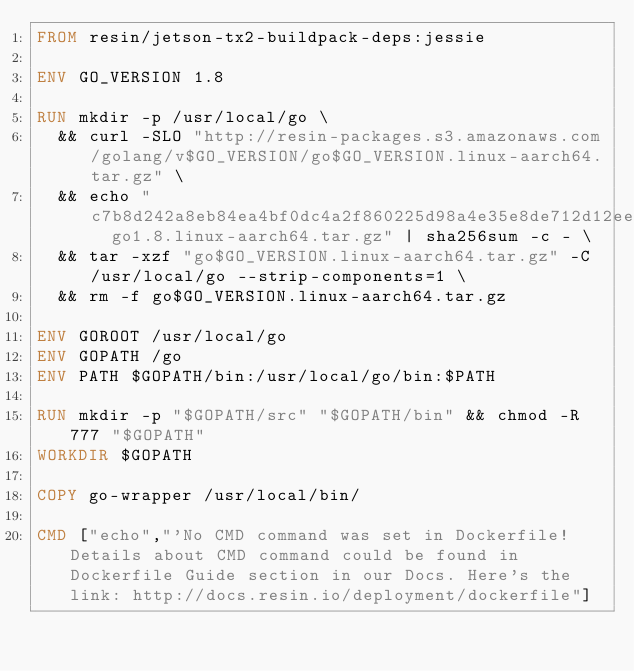<code> <loc_0><loc_0><loc_500><loc_500><_Dockerfile_>FROM resin/jetson-tx2-buildpack-deps:jessie

ENV GO_VERSION 1.8

RUN mkdir -p /usr/local/go \
	&& curl -SLO "http://resin-packages.s3.amazonaws.com/golang/v$GO_VERSION/go$GO_VERSION.linux-aarch64.tar.gz" \
	&& echo "c7b8d242a8eb84ea4bf0dc4a2f860225d98a4e35e8de712d12ee0247f1773854  go1.8.linux-aarch64.tar.gz" | sha256sum -c - \
	&& tar -xzf "go$GO_VERSION.linux-aarch64.tar.gz" -C /usr/local/go --strip-components=1 \
	&& rm -f go$GO_VERSION.linux-aarch64.tar.gz

ENV GOROOT /usr/local/go
ENV GOPATH /go
ENV PATH $GOPATH/bin:/usr/local/go/bin:$PATH

RUN mkdir -p "$GOPATH/src" "$GOPATH/bin" && chmod -R 777 "$GOPATH"
WORKDIR $GOPATH

COPY go-wrapper /usr/local/bin/

CMD ["echo","'No CMD command was set in Dockerfile! Details about CMD command could be found in Dockerfile Guide section in our Docs. Here's the link: http://docs.resin.io/deployment/dockerfile"]
</code> 